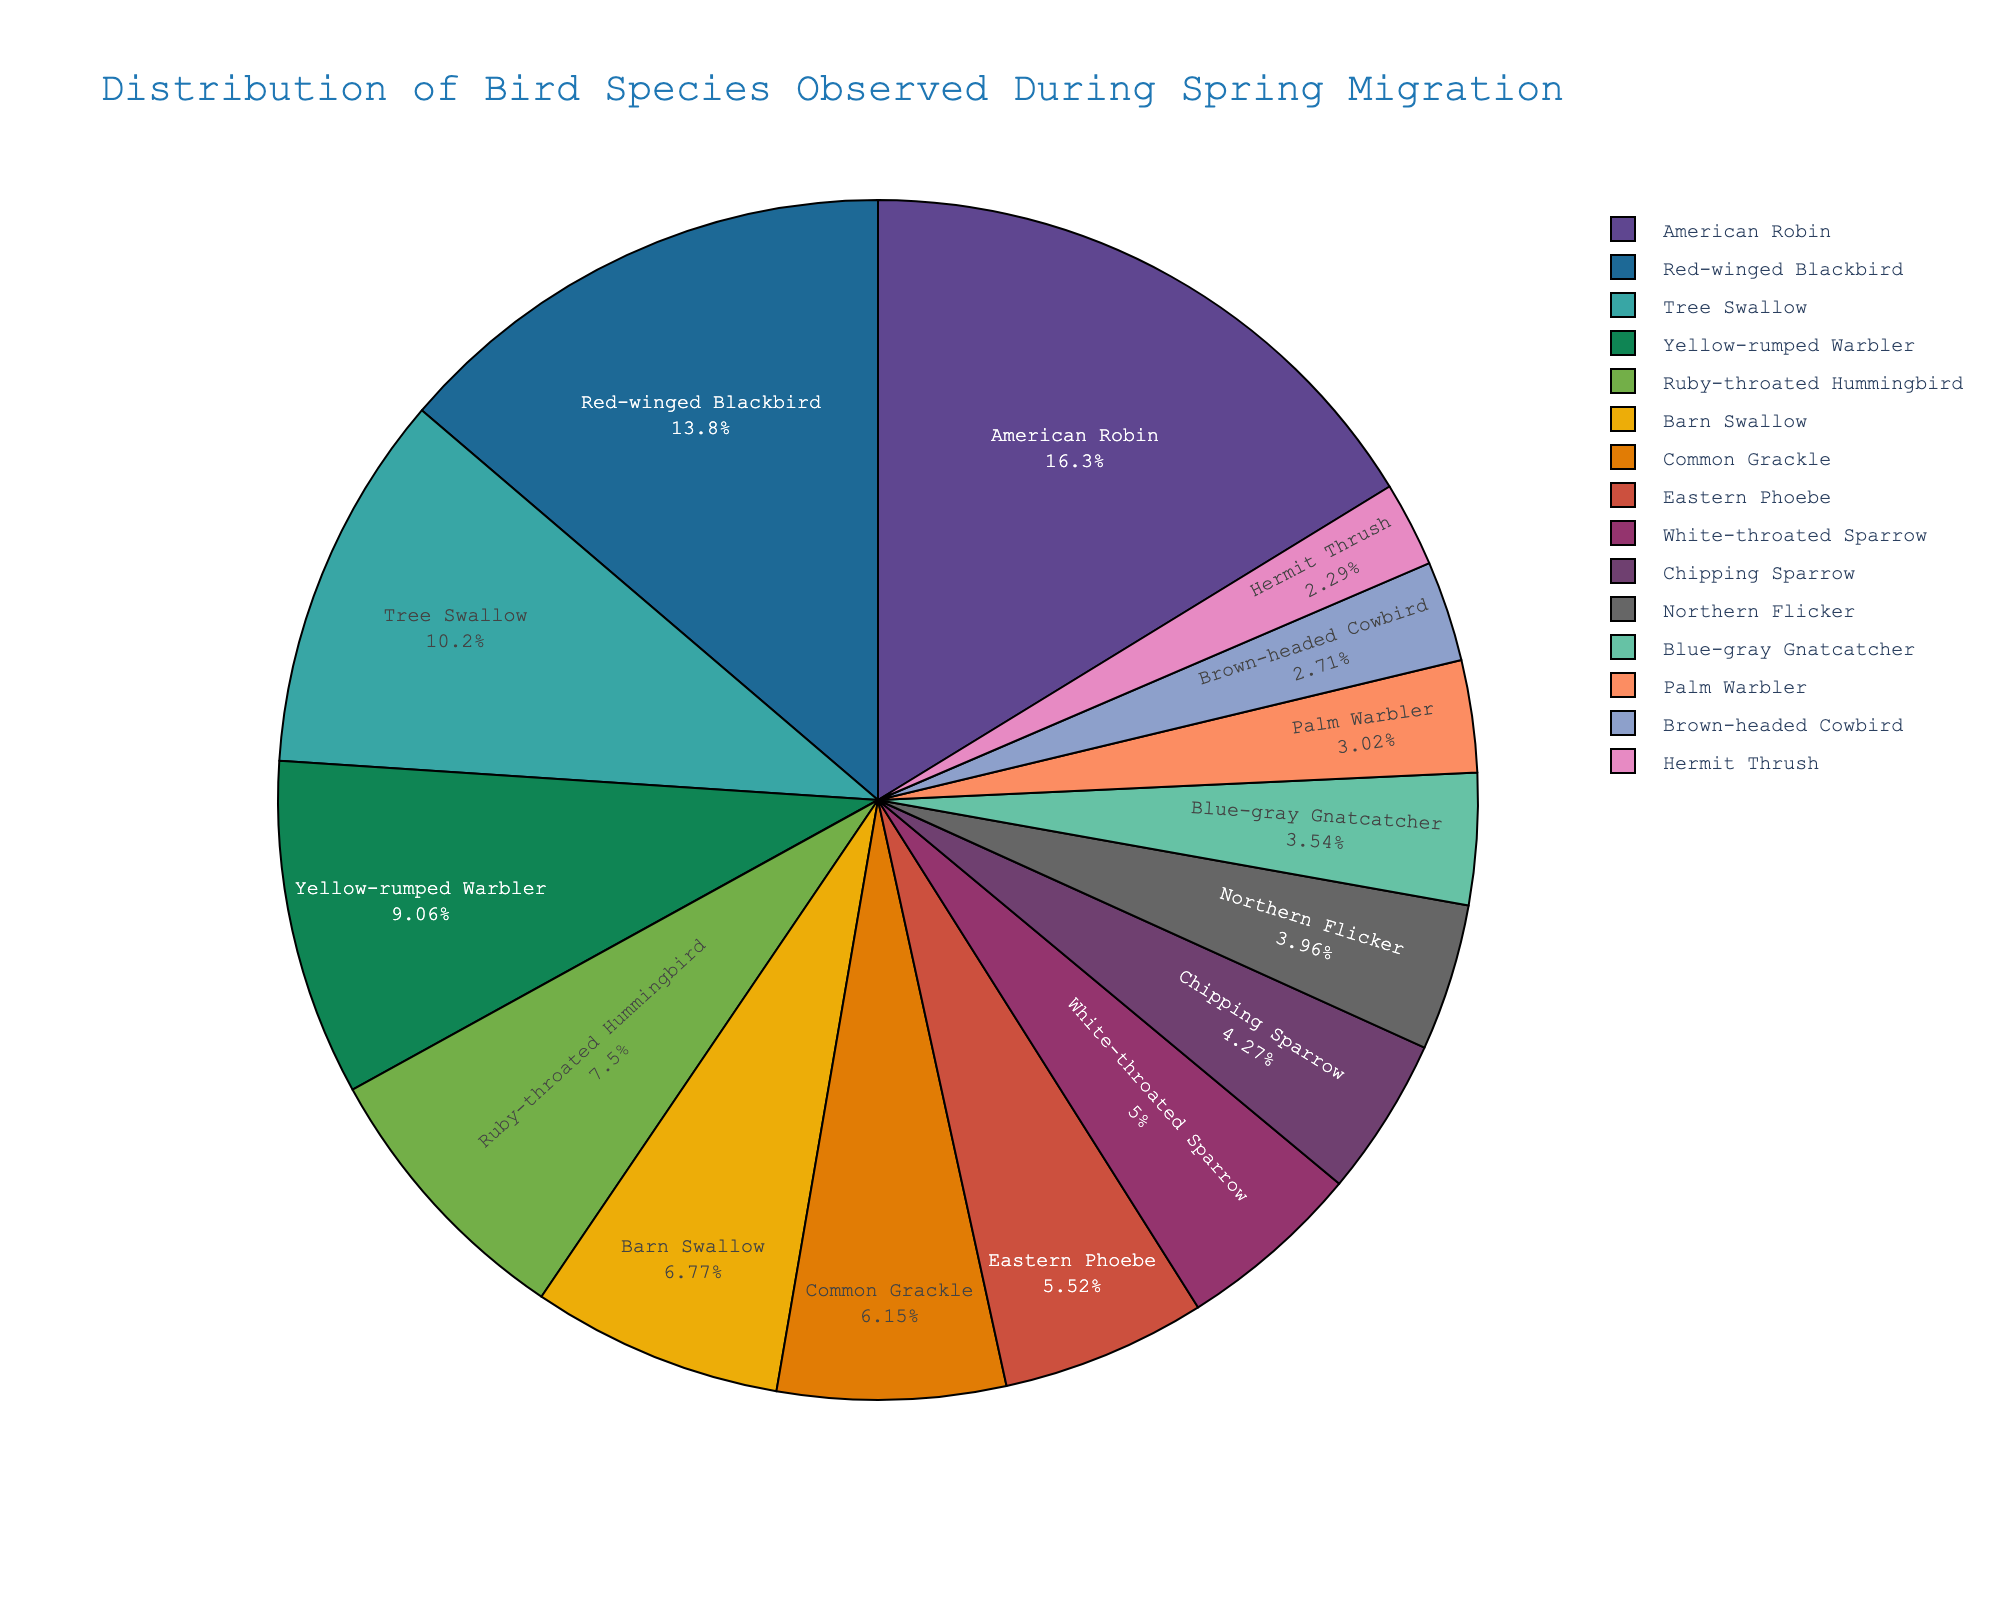What is the percentage of American Robins observed during the spring migration? The pie chart represents the distribution of bird species by their percentage share. Identify American Robin slice and read the percentage label.
Answer: About 19.0% Which bird species has the second highest count observed during the spring migration? To find the species with the second highest count, first note the species with the highest count, which is American Robin, then locate the slice with the next largest size which is Red-winged Blackbird.
Answer: Red-winged Blackbird What is the combined percentage of Tree Swallows and Barn Swallows? Locate both Tree Swallow and Barn Swallow slices, then add their percentage values together. Tree Swallow slice shows approximately 11.9% and Barn Swallow slice shows 7.9%. So, 11.9% + 7.9% = 19.8%.
Answer: 19.8% How does the count of Yellow-rumped Warblers compare to Ruby-throated Hummingbirds? Compare the size of the slices for Yellow-rumped Warbler and Ruby-throated Hummingbird. Since Yellow-rumped Warbler’s slice is slightly larger than Ruby-throated Hummingbird, it indicates a higher count.
Answer: Yellow-rumped Warbler count is larger What proportion of the total bird population does the Northern Flicker represent? Identify the slice for Northern Flicker and read its percentage, which should be available within the pie chart.
Answer: About 4.6% Is the count of Brown-headed Cowbirds greater than that of Hermit Thrushes? Compare the sizes of the slices for Brown-headed Cowbird and Hermit Thrush. Since the Brown-headed Cowbird slice is larger, it indicates that the count is greater.
Answer: Yes How many species are observed with counts greater than 100? Identify and count the species slices with percentage labels corresponding to counts above 100. This includes American Robin (156), Red-winged Blackbird (132) and Tree Swallow (98, but this is less than 100).
Answer: 2 species What is the total count of birds for the top three most observed species? The top three species by count are American Robin (156), Red-winged Blackbird (132), and Tree Swallow (98). Sum these counts to get the total: 156 + 132 + 98 = 386.
Answer: 386 Which species occupies the smallest percentage of the pie chart? Observe the slices to identify the smallest one, which represents the species with the lowest count. The smallest slice is for Hermit Thrush.
Answer: Hermit Thrush By approximately how much does the count of Common Grackles differ from that of Eastern Phoebes? Subtract the count of Eastern Phoebes (53) from the count of Common Grackles (59). 59 - 53 = 6.
Answer: 6 